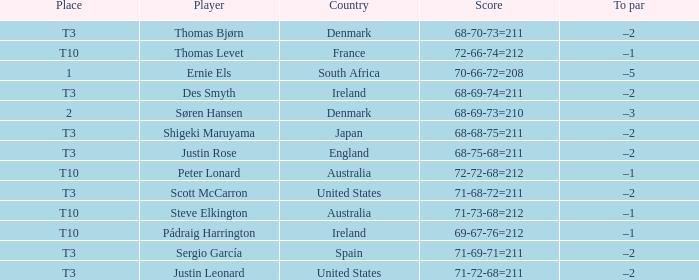What was Australia's score when Peter Lonard played? 72-72-68=212. 